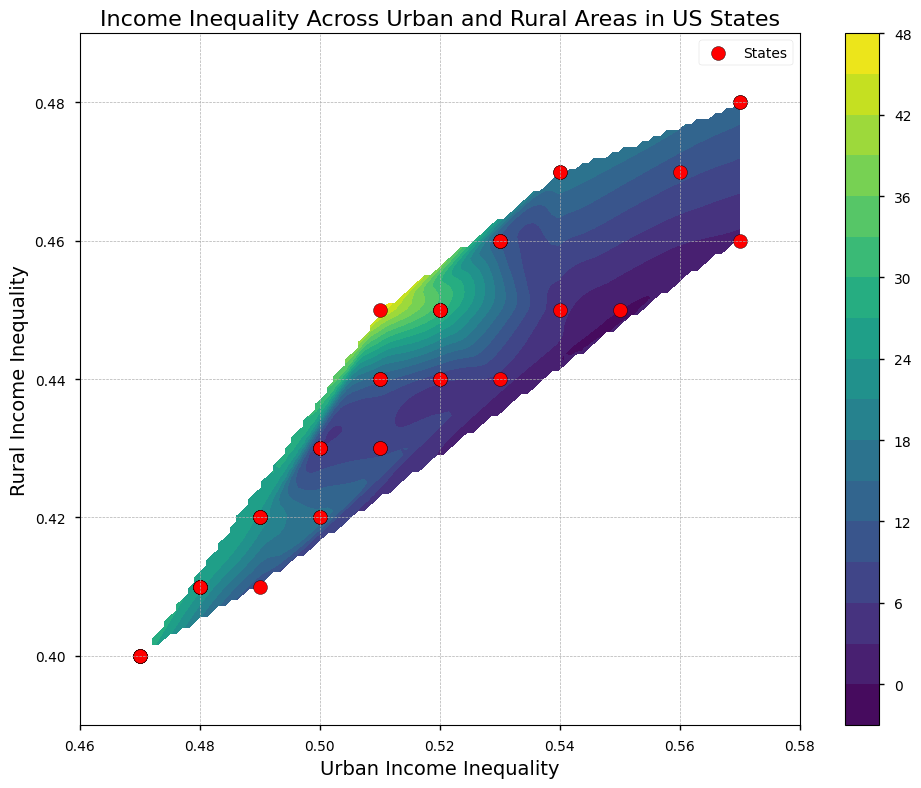Which state has the highest urban income inequality? By looking at the scatter points, we identify the state with the highest value on the x-axis. Massachusetts and Connecticut have the largest x values, both around 0.57.
Answer: Massachusetts and Connecticut Which states have both urban and rural income inequality values above 0.50? Observing the scatter points, we can see which states are situated to the right and above the 0.50 marks on both axes. California, Texas, New York, New Jersey, Virginia, Washington, Maryland, Colorado, Oregon, and Nevada meet these criteria.
Answer: California, Texas, New York, New Jersey, Virginia, Washington, Maryland, Colorado, Oregon, Nevada What's the average of the highest urban and rural income inequality values? The highest urban income inequality is approximately 0.57 and the highest rural income inequality is about 0.48. The average is obtained by adding these two values and dividing by 2: (0.57 + 0.48) / 2 = 0.525
Answer: 0.525 Which three states have urban income inequality around 0.50 and how do their rural income inequality values compare? We look for scatter points around 0.50 on the x-axis. Ohio, Tennessee, Indiana, Oklahoma, and Minnesota fall near this mark. Their rural income inequality values vary between 0.42 and 0.43 approximately.
Answer: Ohio, Tennessee, Indiana, Oklahoma, Minnesota Is there a state where urban income inequality equals rural income inequality? Observing the scatter plot, we identify if there's any point on the line where x equals y. No state has equal values for urban and rural income inequality, as all scatter points are above or below the line y = x.
Answer: No 